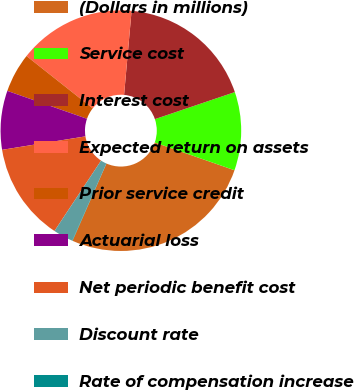Convert chart to OTSL. <chart><loc_0><loc_0><loc_500><loc_500><pie_chart><fcel>(Dollars in millions)<fcel>Service cost<fcel>Interest cost<fcel>Expected return on assets<fcel>Prior service credit<fcel>Actuarial loss<fcel>Net periodic benefit cost<fcel>Discount rate<fcel>Rate of compensation increase<nl><fcel>26.25%<fcel>10.53%<fcel>18.39%<fcel>15.77%<fcel>5.29%<fcel>7.91%<fcel>13.15%<fcel>2.67%<fcel>0.05%<nl></chart> 